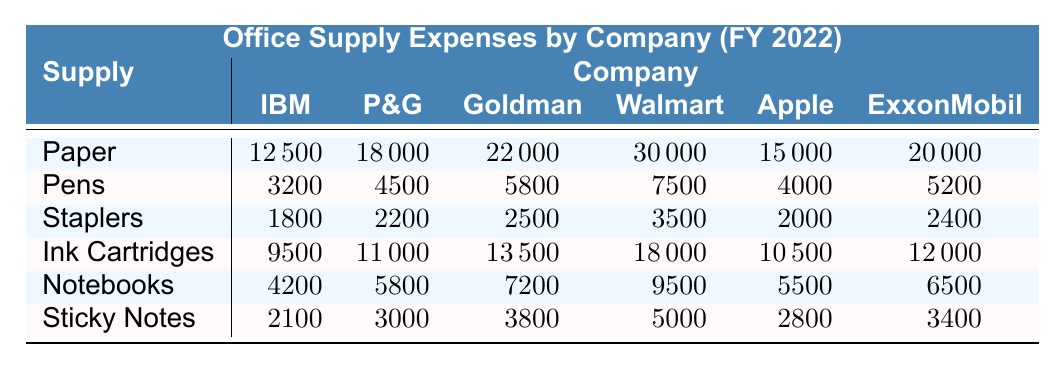What is the total expense for Walmart on office supplies? To find the total expense for Walmart, we add up the expenses of all items: 30000 (Paper) + 7500 (Pens) + 3500 (Staplers) + 18000 (Ink Cartridges) + 9500 (Notebooks) + 5000 (Sticky Notes) = 60000.
Answer: 60000 Which company spent the most on Ink Cartridges? Looking at the column for Ink Cartridges, Walmart has the highest expense of 18000 compared to other companies.
Answer: Walmart What is the difference in total office supplies expense between Goldman Sachs and Apple? First, calculate Goldman Sachs' total expenses: 22000 + 5800 + 2500 + 13500 + 7200 + 3800 = 52000. Then, calculate Apple's total expenses: 15000 + 4000 + 2000 + 10500 + 5500 + 2800 = 40000. The difference is 52000 - 40000 = 12000.
Answer: 12000 How many companies spent over 20000 on Paper supplies? By checking the Paper row, Walmart (30000) and Goldman Sachs (22000) both spent over 20000 on Paper. Thus, the count is 2.
Answer: 2 What is the average amount spent on Sticky Notes by all companies? The amounts spent on Sticky Notes are: 2100 (IBM), 3000 (Procter & Gamble), 3800 (Goldman Sachs), 5000 (Walmart), 2800 (Apple), and 3400 (ExxonMobil), giving us a total of 2100 + 3000 + 3800 + 5000 + 2800 + 3400 = 20100. We divide this total by the number of companies (6) to get the average: 20100 / 6 = 3350.
Answer: 3350 Which category had the highest total expenses across all companies? Calculating the total expenses for each item: Paper = 12500 + 18000 + 22000 + 30000 + 15000 + 20000 = 117500; Pens = 3200 + 4500 + 5800 + 7500 + 4000 + 5200 = 30700; Staplers = 1800 + 2200 + 2500 + 3500 + 2000 + 2400 = 17400; Ink Cartridges = 9500 + 11000 + 13500 + 18000 + 10500 + 12000 = 80000; Notebooks = 4200 + 5800 + 7200 + 9500 + 5500 + 6500 = 36700; Sticky Notes = 2100 + 3000 + 3800 + 5000 + 2800 + 3400 = 20100. The highest category is Paper with 117500.
Answer: Paper Did Procter & Gamble spend more on Staplers than ExxonMobil? Procter & Gamble spent 2200 on Staplers while ExxonMobil spent 2400. Since 2200 is less than 2400, the statement is false.
Answer: No What is the total cost of office supplies for Apple? To find Apple's total expense, we add each item: 15000 (Paper) + 4000 (Pens) + 2000 (Staplers) + 10500 (Ink Cartridges) + 5500 (Notebooks) + 2800 (Sticky Notes) = 40000.
Answer: 40000 Which company had the lowest total expenses across all supplied items? Calculating total expenses for each company reveals that IBM had the lowest total of 12500 + 3200 + 1800 + 9500 + 4200 + 2100 = 32000.
Answer: IBM How much did Goldman Sachs spend on Notebooks compared to the average of all companies? Goldman Sachs spent 7200 on Notebooks. The average expense on Notebooks across all companies is calculated as follows: (4200 + 5800 + 7200 + 9500 + 5500 + 6500) / 6 = 6100. Thus, 7200 is higher than the average of 6100.
Answer: Yes 